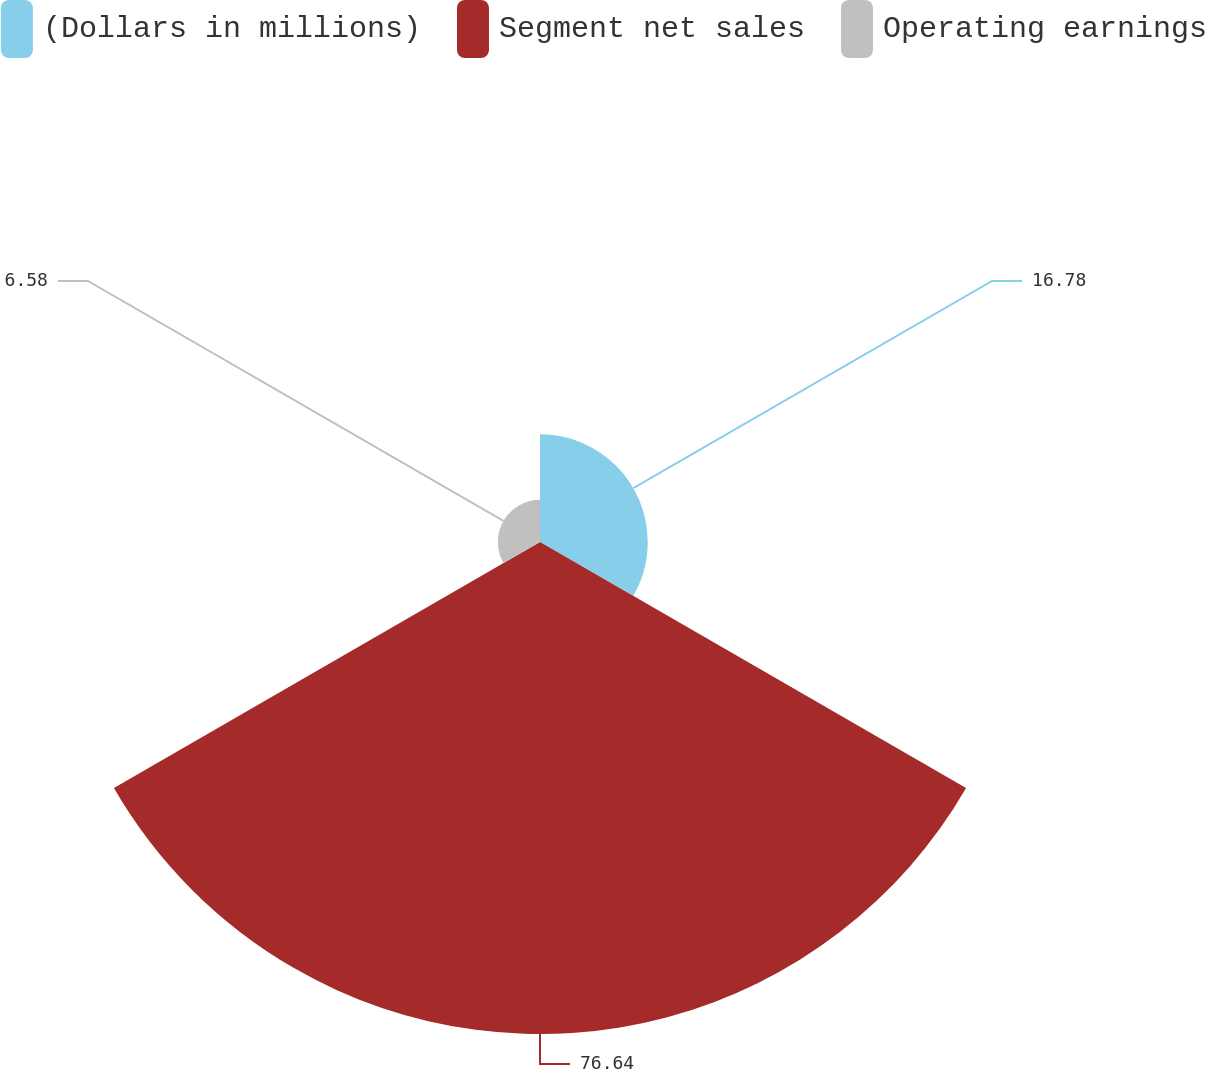<chart> <loc_0><loc_0><loc_500><loc_500><pie_chart><fcel>(Dollars in millions)<fcel>Segment net sales<fcel>Operating earnings<nl><fcel>16.78%<fcel>76.64%<fcel>6.58%<nl></chart> 